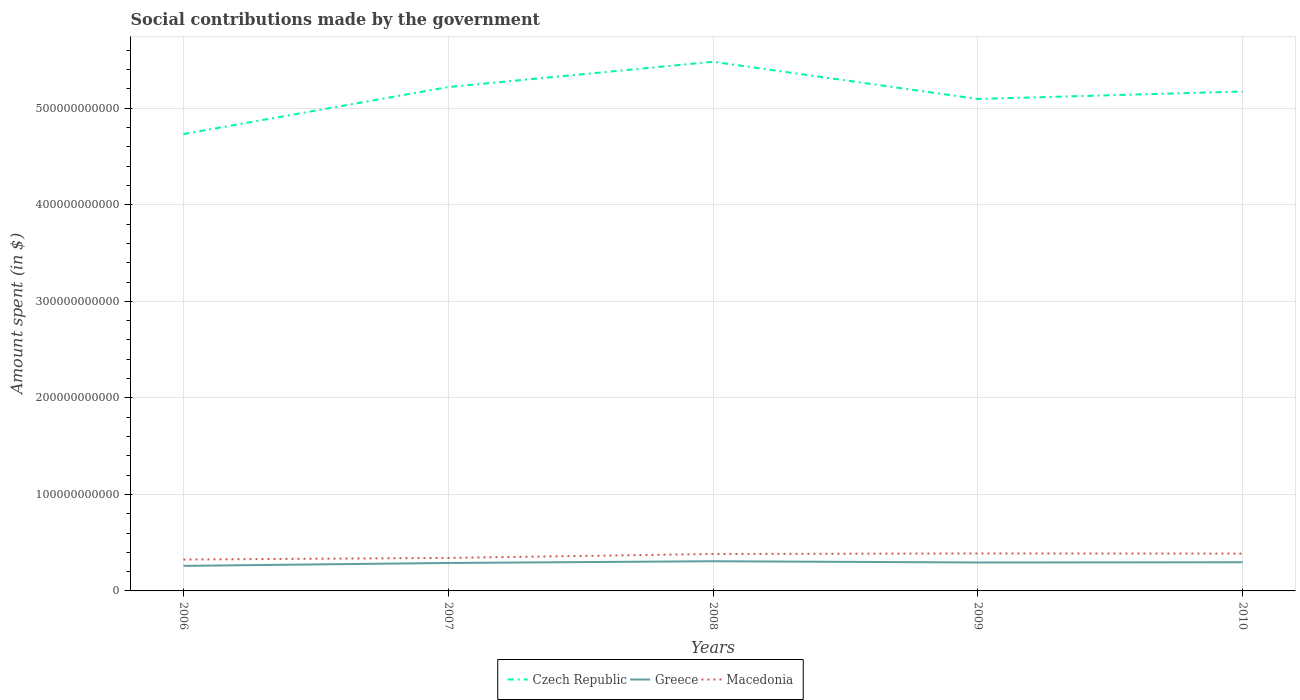Across all years, what is the maximum amount spent on social contributions in Greece?
Your answer should be very brief. 2.59e+1. In which year was the amount spent on social contributions in Macedonia maximum?
Your response must be concise. 2006. What is the total amount spent on social contributions in Czech Republic in the graph?
Give a very brief answer. 1.24e+1. What is the difference between the highest and the second highest amount spent on social contributions in Greece?
Your answer should be compact. 4.81e+09. Is the amount spent on social contributions in Greece strictly greater than the amount spent on social contributions in Macedonia over the years?
Make the answer very short. Yes. How many years are there in the graph?
Provide a succinct answer. 5. What is the difference between two consecutive major ticks on the Y-axis?
Provide a short and direct response. 1.00e+11. Are the values on the major ticks of Y-axis written in scientific E-notation?
Give a very brief answer. No. Where does the legend appear in the graph?
Offer a very short reply. Bottom center. What is the title of the graph?
Offer a very short reply. Social contributions made by the government. Does "Sierra Leone" appear as one of the legend labels in the graph?
Provide a succinct answer. No. What is the label or title of the Y-axis?
Make the answer very short. Amount spent (in $). What is the Amount spent (in $) of Czech Republic in 2006?
Offer a terse response. 4.73e+11. What is the Amount spent (in $) of Greece in 2006?
Provide a short and direct response. 2.59e+1. What is the Amount spent (in $) in Macedonia in 2006?
Provide a short and direct response. 3.25e+1. What is the Amount spent (in $) in Czech Republic in 2007?
Your answer should be compact. 5.22e+11. What is the Amount spent (in $) in Greece in 2007?
Make the answer very short. 2.90e+1. What is the Amount spent (in $) of Macedonia in 2007?
Give a very brief answer. 3.42e+1. What is the Amount spent (in $) of Czech Republic in 2008?
Ensure brevity in your answer.  5.48e+11. What is the Amount spent (in $) of Greece in 2008?
Make the answer very short. 3.07e+1. What is the Amount spent (in $) in Macedonia in 2008?
Ensure brevity in your answer.  3.82e+1. What is the Amount spent (in $) in Czech Republic in 2009?
Your answer should be very brief. 5.10e+11. What is the Amount spent (in $) in Greece in 2009?
Offer a terse response. 2.95e+1. What is the Amount spent (in $) of Macedonia in 2009?
Offer a terse response. 3.88e+1. What is the Amount spent (in $) in Czech Republic in 2010?
Offer a terse response. 5.17e+11. What is the Amount spent (in $) of Greece in 2010?
Offer a terse response. 2.97e+1. What is the Amount spent (in $) of Macedonia in 2010?
Ensure brevity in your answer.  3.87e+1. Across all years, what is the maximum Amount spent (in $) in Czech Republic?
Your answer should be very brief. 5.48e+11. Across all years, what is the maximum Amount spent (in $) in Greece?
Make the answer very short. 3.07e+1. Across all years, what is the maximum Amount spent (in $) of Macedonia?
Offer a terse response. 3.88e+1. Across all years, what is the minimum Amount spent (in $) of Czech Republic?
Make the answer very short. 4.73e+11. Across all years, what is the minimum Amount spent (in $) of Greece?
Offer a terse response. 2.59e+1. Across all years, what is the minimum Amount spent (in $) in Macedonia?
Your answer should be compact. 3.25e+1. What is the total Amount spent (in $) in Czech Republic in the graph?
Provide a short and direct response. 2.57e+12. What is the total Amount spent (in $) of Greece in the graph?
Keep it short and to the point. 1.45e+11. What is the total Amount spent (in $) of Macedonia in the graph?
Provide a short and direct response. 1.82e+11. What is the difference between the Amount spent (in $) of Czech Republic in 2006 and that in 2007?
Ensure brevity in your answer.  -4.87e+1. What is the difference between the Amount spent (in $) of Greece in 2006 and that in 2007?
Provide a short and direct response. -3.02e+09. What is the difference between the Amount spent (in $) in Macedonia in 2006 and that in 2007?
Give a very brief answer. -1.70e+09. What is the difference between the Amount spent (in $) in Czech Republic in 2006 and that in 2008?
Make the answer very short. -7.49e+1. What is the difference between the Amount spent (in $) of Greece in 2006 and that in 2008?
Ensure brevity in your answer.  -4.81e+09. What is the difference between the Amount spent (in $) in Macedonia in 2006 and that in 2008?
Give a very brief answer. -5.74e+09. What is the difference between the Amount spent (in $) of Czech Republic in 2006 and that in 2009?
Give a very brief answer. -3.63e+1. What is the difference between the Amount spent (in $) in Greece in 2006 and that in 2009?
Give a very brief answer. -3.51e+09. What is the difference between the Amount spent (in $) of Macedonia in 2006 and that in 2009?
Your answer should be very brief. -6.33e+09. What is the difference between the Amount spent (in $) of Czech Republic in 2006 and that in 2010?
Offer a very short reply. -4.41e+1. What is the difference between the Amount spent (in $) of Greece in 2006 and that in 2010?
Make the answer very short. -3.76e+09. What is the difference between the Amount spent (in $) in Macedonia in 2006 and that in 2010?
Your response must be concise. -6.18e+09. What is the difference between the Amount spent (in $) in Czech Republic in 2007 and that in 2008?
Provide a short and direct response. -2.62e+1. What is the difference between the Amount spent (in $) of Greece in 2007 and that in 2008?
Keep it short and to the point. -1.79e+09. What is the difference between the Amount spent (in $) in Macedonia in 2007 and that in 2008?
Your answer should be compact. -4.04e+09. What is the difference between the Amount spent (in $) of Czech Republic in 2007 and that in 2009?
Provide a short and direct response. 1.24e+1. What is the difference between the Amount spent (in $) of Greece in 2007 and that in 2009?
Provide a succinct answer. -4.96e+08. What is the difference between the Amount spent (in $) of Macedonia in 2007 and that in 2009?
Offer a terse response. -4.63e+09. What is the difference between the Amount spent (in $) in Czech Republic in 2007 and that in 2010?
Your response must be concise. 4.62e+09. What is the difference between the Amount spent (in $) in Greece in 2007 and that in 2010?
Provide a short and direct response. -7.40e+08. What is the difference between the Amount spent (in $) in Macedonia in 2007 and that in 2010?
Provide a succinct answer. -4.48e+09. What is the difference between the Amount spent (in $) in Czech Republic in 2008 and that in 2009?
Provide a short and direct response. 3.85e+1. What is the difference between the Amount spent (in $) in Greece in 2008 and that in 2009?
Your response must be concise. 1.29e+09. What is the difference between the Amount spent (in $) of Macedonia in 2008 and that in 2009?
Your answer should be compact. -5.88e+08. What is the difference between the Amount spent (in $) of Czech Republic in 2008 and that in 2010?
Provide a succinct answer. 3.08e+1. What is the difference between the Amount spent (in $) in Greece in 2008 and that in 2010?
Provide a succinct answer. 1.05e+09. What is the difference between the Amount spent (in $) in Macedonia in 2008 and that in 2010?
Provide a succinct answer. -4.38e+08. What is the difference between the Amount spent (in $) in Czech Republic in 2009 and that in 2010?
Give a very brief answer. -7.76e+09. What is the difference between the Amount spent (in $) of Greece in 2009 and that in 2010?
Provide a succinct answer. -2.44e+08. What is the difference between the Amount spent (in $) of Macedonia in 2009 and that in 2010?
Make the answer very short. 1.50e+08. What is the difference between the Amount spent (in $) in Czech Republic in 2006 and the Amount spent (in $) in Greece in 2007?
Offer a very short reply. 4.44e+11. What is the difference between the Amount spent (in $) of Czech Republic in 2006 and the Amount spent (in $) of Macedonia in 2007?
Keep it short and to the point. 4.39e+11. What is the difference between the Amount spent (in $) in Greece in 2006 and the Amount spent (in $) in Macedonia in 2007?
Ensure brevity in your answer.  -8.26e+09. What is the difference between the Amount spent (in $) in Czech Republic in 2006 and the Amount spent (in $) in Greece in 2008?
Offer a terse response. 4.43e+11. What is the difference between the Amount spent (in $) in Czech Republic in 2006 and the Amount spent (in $) in Macedonia in 2008?
Give a very brief answer. 4.35e+11. What is the difference between the Amount spent (in $) of Greece in 2006 and the Amount spent (in $) of Macedonia in 2008?
Offer a terse response. -1.23e+1. What is the difference between the Amount spent (in $) in Czech Republic in 2006 and the Amount spent (in $) in Greece in 2009?
Provide a short and direct response. 4.44e+11. What is the difference between the Amount spent (in $) in Czech Republic in 2006 and the Amount spent (in $) in Macedonia in 2009?
Your response must be concise. 4.34e+11. What is the difference between the Amount spent (in $) in Greece in 2006 and the Amount spent (in $) in Macedonia in 2009?
Your answer should be compact. -1.29e+1. What is the difference between the Amount spent (in $) in Czech Republic in 2006 and the Amount spent (in $) in Greece in 2010?
Your answer should be compact. 4.44e+11. What is the difference between the Amount spent (in $) in Czech Republic in 2006 and the Amount spent (in $) in Macedonia in 2010?
Provide a succinct answer. 4.35e+11. What is the difference between the Amount spent (in $) in Greece in 2006 and the Amount spent (in $) in Macedonia in 2010?
Provide a succinct answer. -1.27e+1. What is the difference between the Amount spent (in $) of Czech Republic in 2007 and the Amount spent (in $) of Greece in 2008?
Your response must be concise. 4.91e+11. What is the difference between the Amount spent (in $) in Czech Republic in 2007 and the Amount spent (in $) in Macedonia in 2008?
Keep it short and to the point. 4.84e+11. What is the difference between the Amount spent (in $) in Greece in 2007 and the Amount spent (in $) in Macedonia in 2008?
Make the answer very short. -9.29e+09. What is the difference between the Amount spent (in $) of Czech Republic in 2007 and the Amount spent (in $) of Greece in 2009?
Provide a short and direct response. 4.93e+11. What is the difference between the Amount spent (in $) in Czech Republic in 2007 and the Amount spent (in $) in Macedonia in 2009?
Offer a terse response. 4.83e+11. What is the difference between the Amount spent (in $) in Greece in 2007 and the Amount spent (in $) in Macedonia in 2009?
Offer a very short reply. -9.88e+09. What is the difference between the Amount spent (in $) of Czech Republic in 2007 and the Amount spent (in $) of Greece in 2010?
Provide a succinct answer. 4.92e+11. What is the difference between the Amount spent (in $) of Czech Republic in 2007 and the Amount spent (in $) of Macedonia in 2010?
Ensure brevity in your answer.  4.83e+11. What is the difference between the Amount spent (in $) of Greece in 2007 and the Amount spent (in $) of Macedonia in 2010?
Provide a short and direct response. -9.73e+09. What is the difference between the Amount spent (in $) in Czech Republic in 2008 and the Amount spent (in $) in Greece in 2009?
Ensure brevity in your answer.  5.19e+11. What is the difference between the Amount spent (in $) in Czech Republic in 2008 and the Amount spent (in $) in Macedonia in 2009?
Give a very brief answer. 5.09e+11. What is the difference between the Amount spent (in $) in Greece in 2008 and the Amount spent (in $) in Macedonia in 2009?
Give a very brief answer. -8.09e+09. What is the difference between the Amount spent (in $) of Czech Republic in 2008 and the Amount spent (in $) of Greece in 2010?
Your answer should be very brief. 5.18e+11. What is the difference between the Amount spent (in $) in Czech Republic in 2008 and the Amount spent (in $) in Macedonia in 2010?
Provide a short and direct response. 5.09e+11. What is the difference between the Amount spent (in $) in Greece in 2008 and the Amount spent (in $) in Macedonia in 2010?
Provide a succinct answer. -7.94e+09. What is the difference between the Amount spent (in $) of Czech Republic in 2009 and the Amount spent (in $) of Greece in 2010?
Make the answer very short. 4.80e+11. What is the difference between the Amount spent (in $) of Czech Republic in 2009 and the Amount spent (in $) of Macedonia in 2010?
Your answer should be compact. 4.71e+11. What is the difference between the Amount spent (in $) of Greece in 2009 and the Amount spent (in $) of Macedonia in 2010?
Give a very brief answer. -9.23e+09. What is the average Amount spent (in $) in Czech Republic per year?
Provide a short and direct response. 5.14e+11. What is the average Amount spent (in $) in Greece per year?
Make the answer very short. 2.90e+1. What is the average Amount spent (in $) in Macedonia per year?
Provide a short and direct response. 3.65e+1. In the year 2006, what is the difference between the Amount spent (in $) of Czech Republic and Amount spent (in $) of Greece?
Provide a short and direct response. 4.47e+11. In the year 2006, what is the difference between the Amount spent (in $) of Czech Republic and Amount spent (in $) of Macedonia?
Provide a short and direct response. 4.41e+11. In the year 2006, what is the difference between the Amount spent (in $) of Greece and Amount spent (in $) of Macedonia?
Offer a terse response. -6.57e+09. In the year 2007, what is the difference between the Amount spent (in $) in Czech Republic and Amount spent (in $) in Greece?
Your response must be concise. 4.93e+11. In the year 2007, what is the difference between the Amount spent (in $) of Czech Republic and Amount spent (in $) of Macedonia?
Your response must be concise. 4.88e+11. In the year 2007, what is the difference between the Amount spent (in $) of Greece and Amount spent (in $) of Macedonia?
Keep it short and to the point. -5.25e+09. In the year 2008, what is the difference between the Amount spent (in $) in Czech Republic and Amount spent (in $) in Greece?
Make the answer very short. 5.17e+11. In the year 2008, what is the difference between the Amount spent (in $) of Czech Republic and Amount spent (in $) of Macedonia?
Your answer should be compact. 5.10e+11. In the year 2008, what is the difference between the Amount spent (in $) in Greece and Amount spent (in $) in Macedonia?
Provide a short and direct response. -7.50e+09. In the year 2009, what is the difference between the Amount spent (in $) in Czech Republic and Amount spent (in $) in Greece?
Your answer should be compact. 4.80e+11. In the year 2009, what is the difference between the Amount spent (in $) of Czech Republic and Amount spent (in $) of Macedonia?
Provide a succinct answer. 4.71e+11. In the year 2009, what is the difference between the Amount spent (in $) in Greece and Amount spent (in $) in Macedonia?
Offer a very short reply. -9.38e+09. In the year 2010, what is the difference between the Amount spent (in $) in Czech Republic and Amount spent (in $) in Greece?
Your response must be concise. 4.88e+11. In the year 2010, what is the difference between the Amount spent (in $) in Czech Republic and Amount spent (in $) in Macedonia?
Keep it short and to the point. 4.79e+11. In the year 2010, what is the difference between the Amount spent (in $) in Greece and Amount spent (in $) in Macedonia?
Offer a very short reply. -8.99e+09. What is the ratio of the Amount spent (in $) of Czech Republic in 2006 to that in 2007?
Your answer should be very brief. 0.91. What is the ratio of the Amount spent (in $) of Greece in 2006 to that in 2007?
Provide a succinct answer. 0.9. What is the ratio of the Amount spent (in $) in Macedonia in 2006 to that in 2007?
Your answer should be very brief. 0.95. What is the ratio of the Amount spent (in $) in Czech Republic in 2006 to that in 2008?
Provide a short and direct response. 0.86. What is the ratio of the Amount spent (in $) in Greece in 2006 to that in 2008?
Offer a very short reply. 0.84. What is the ratio of the Amount spent (in $) in Czech Republic in 2006 to that in 2009?
Your response must be concise. 0.93. What is the ratio of the Amount spent (in $) of Greece in 2006 to that in 2009?
Your answer should be very brief. 0.88. What is the ratio of the Amount spent (in $) of Macedonia in 2006 to that in 2009?
Make the answer very short. 0.84. What is the ratio of the Amount spent (in $) in Czech Republic in 2006 to that in 2010?
Your answer should be compact. 0.91. What is the ratio of the Amount spent (in $) in Greece in 2006 to that in 2010?
Ensure brevity in your answer.  0.87. What is the ratio of the Amount spent (in $) of Macedonia in 2006 to that in 2010?
Give a very brief answer. 0.84. What is the ratio of the Amount spent (in $) of Czech Republic in 2007 to that in 2008?
Offer a terse response. 0.95. What is the ratio of the Amount spent (in $) of Greece in 2007 to that in 2008?
Your response must be concise. 0.94. What is the ratio of the Amount spent (in $) of Macedonia in 2007 to that in 2008?
Provide a succinct answer. 0.89. What is the ratio of the Amount spent (in $) in Czech Republic in 2007 to that in 2009?
Give a very brief answer. 1.02. What is the ratio of the Amount spent (in $) of Greece in 2007 to that in 2009?
Keep it short and to the point. 0.98. What is the ratio of the Amount spent (in $) of Macedonia in 2007 to that in 2009?
Offer a very short reply. 0.88. What is the ratio of the Amount spent (in $) in Czech Republic in 2007 to that in 2010?
Give a very brief answer. 1.01. What is the ratio of the Amount spent (in $) in Greece in 2007 to that in 2010?
Give a very brief answer. 0.98. What is the ratio of the Amount spent (in $) of Macedonia in 2007 to that in 2010?
Your answer should be very brief. 0.88. What is the ratio of the Amount spent (in $) in Czech Republic in 2008 to that in 2009?
Provide a short and direct response. 1.08. What is the ratio of the Amount spent (in $) of Greece in 2008 to that in 2009?
Your response must be concise. 1.04. What is the ratio of the Amount spent (in $) of Macedonia in 2008 to that in 2009?
Give a very brief answer. 0.98. What is the ratio of the Amount spent (in $) in Czech Republic in 2008 to that in 2010?
Provide a succinct answer. 1.06. What is the ratio of the Amount spent (in $) of Greece in 2008 to that in 2010?
Your answer should be very brief. 1.04. What is the ratio of the Amount spent (in $) in Macedonia in 2008 to that in 2010?
Your answer should be compact. 0.99. What is the ratio of the Amount spent (in $) in Czech Republic in 2009 to that in 2010?
Provide a short and direct response. 0.98. What is the ratio of the Amount spent (in $) of Greece in 2009 to that in 2010?
Your response must be concise. 0.99. What is the ratio of the Amount spent (in $) of Macedonia in 2009 to that in 2010?
Offer a terse response. 1. What is the difference between the highest and the second highest Amount spent (in $) in Czech Republic?
Provide a succinct answer. 2.62e+1. What is the difference between the highest and the second highest Amount spent (in $) in Greece?
Keep it short and to the point. 1.05e+09. What is the difference between the highest and the second highest Amount spent (in $) in Macedonia?
Your answer should be compact. 1.50e+08. What is the difference between the highest and the lowest Amount spent (in $) in Czech Republic?
Ensure brevity in your answer.  7.49e+1. What is the difference between the highest and the lowest Amount spent (in $) of Greece?
Offer a very short reply. 4.81e+09. What is the difference between the highest and the lowest Amount spent (in $) of Macedonia?
Provide a short and direct response. 6.33e+09. 